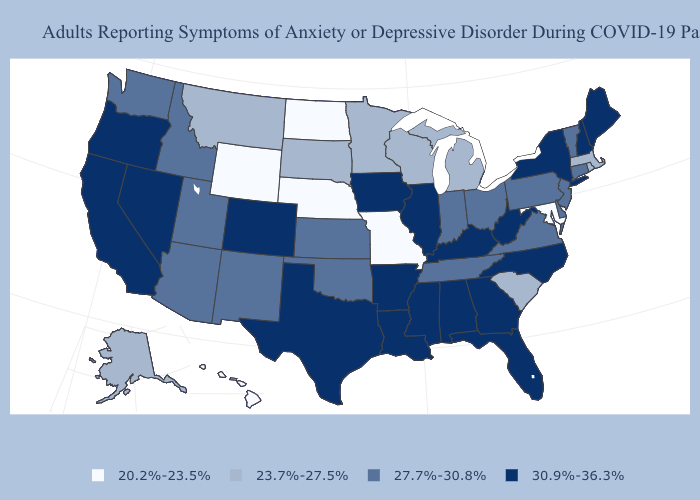What is the value of South Carolina?
Be succinct. 23.7%-27.5%. What is the highest value in states that border Iowa?
Be succinct. 30.9%-36.3%. Does Idaho have a lower value than North Dakota?
Quick response, please. No. Name the states that have a value in the range 23.7%-27.5%?
Be succinct. Alaska, Massachusetts, Michigan, Minnesota, Montana, Rhode Island, South Carolina, South Dakota, Wisconsin. Name the states that have a value in the range 20.2%-23.5%?
Concise answer only. Hawaii, Maryland, Missouri, Nebraska, North Dakota, Wyoming. What is the value of New York?
Quick response, please. 30.9%-36.3%. What is the value of Pennsylvania?
Give a very brief answer. 27.7%-30.8%. Name the states that have a value in the range 20.2%-23.5%?
Quick response, please. Hawaii, Maryland, Missouri, Nebraska, North Dakota, Wyoming. What is the highest value in the USA?
Give a very brief answer. 30.9%-36.3%. What is the lowest value in the USA?
Keep it brief. 20.2%-23.5%. What is the lowest value in states that border South Dakota?
Keep it brief. 20.2%-23.5%. Which states have the lowest value in the USA?
Be succinct. Hawaii, Maryland, Missouri, Nebraska, North Dakota, Wyoming. Name the states that have a value in the range 30.9%-36.3%?
Quick response, please. Alabama, Arkansas, California, Colorado, Florida, Georgia, Illinois, Iowa, Kentucky, Louisiana, Maine, Mississippi, Nevada, New Hampshire, New York, North Carolina, Oregon, Texas, West Virginia. Name the states that have a value in the range 30.9%-36.3%?
Answer briefly. Alabama, Arkansas, California, Colorado, Florida, Georgia, Illinois, Iowa, Kentucky, Louisiana, Maine, Mississippi, Nevada, New Hampshire, New York, North Carolina, Oregon, Texas, West Virginia. 